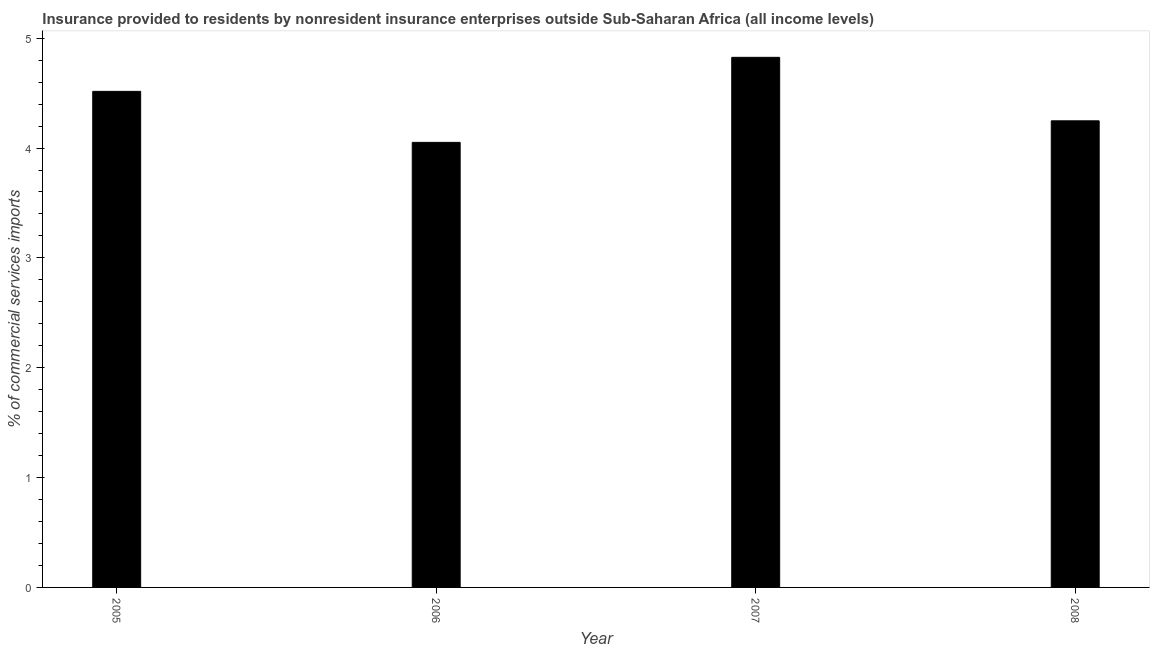Does the graph contain grids?
Offer a very short reply. No. What is the title of the graph?
Offer a very short reply. Insurance provided to residents by nonresident insurance enterprises outside Sub-Saharan Africa (all income levels). What is the label or title of the X-axis?
Provide a short and direct response. Year. What is the label or title of the Y-axis?
Offer a very short reply. % of commercial services imports. What is the insurance provided by non-residents in 2005?
Your response must be concise. 4.52. Across all years, what is the maximum insurance provided by non-residents?
Make the answer very short. 4.83. Across all years, what is the minimum insurance provided by non-residents?
Keep it short and to the point. 4.05. In which year was the insurance provided by non-residents maximum?
Give a very brief answer. 2007. What is the sum of the insurance provided by non-residents?
Keep it short and to the point. 17.64. What is the difference between the insurance provided by non-residents in 2006 and 2008?
Provide a short and direct response. -0.2. What is the average insurance provided by non-residents per year?
Make the answer very short. 4.41. What is the median insurance provided by non-residents?
Your answer should be compact. 4.38. In how many years, is the insurance provided by non-residents greater than 1 %?
Your answer should be compact. 4. What is the ratio of the insurance provided by non-residents in 2005 to that in 2007?
Provide a short and direct response. 0.94. Is the difference between the insurance provided by non-residents in 2005 and 2008 greater than the difference between any two years?
Offer a very short reply. No. What is the difference between the highest and the second highest insurance provided by non-residents?
Offer a very short reply. 0.31. Is the sum of the insurance provided by non-residents in 2005 and 2007 greater than the maximum insurance provided by non-residents across all years?
Offer a terse response. Yes. What is the difference between the highest and the lowest insurance provided by non-residents?
Your answer should be very brief. 0.77. Are all the bars in the graph horizontal?
Your response must be concise. No. What is the difference between two consecutive major ticks on the Y-axis?
Make the answer very short. 1. Are the values on the major ticks of Y-axis written in scientific E-notation?
Give a very brief answer. No. What is the % of commercial services imports in 2005?
Provide a short and direct response. 4.52. What is the % of commercial services imports in 2006?
Give a very brief answer. 4.05. What is the % of commercial services imports of 2007?
Offer a terse response. 4.83. What is the % of commercial services imports in 2008?
Your response must be concise. 4.25. What is the difference between the % of commercial services imports in 2005 and 2006?
Your answer should be compact. 0.46. What is the difference between the % of commercial services imports in 2005 and 2007?
Ensure brevity in your answer.  -0.31. What is the difference between the % of commercial services imports in 2005 and 2008?
Your response must be concise. 0.27. What is the difference between the % of commercial services imports in 2006 and 2007?
Your answer should be compact. -0.77. What is the difference between the % of commercial services imports in 2006 and 2008?
Ensure brevity in your answer.  -0.2. What is the difference between the % of commercial services imports in 2007 and 2008?
Provide a short and direct response. 0.58. What is the ratio of the % of commercial services imports in 2005 to that in 2006?
Your response must be concise. 1.11. What is the ratio of the % of commercial services imports in 2005 to that in 2007?
Make the answer very short. 0.94. What is the ratio of the % of commercial services imports in 2005 to that in 2008?
Your answer should be compact. 1.06. What is the ratio of the % of commercial services imports in 2006 to that in 2007?
Provide a succinct answer. 0.84. What is the ratio of the % of commercial services imports in 2006 to that in 2008?
Make the answer very short. 0.95. What is the ratio of the % of commercial services imports in 2007 to that in 2008?
Offer a terse response. 1.14. 